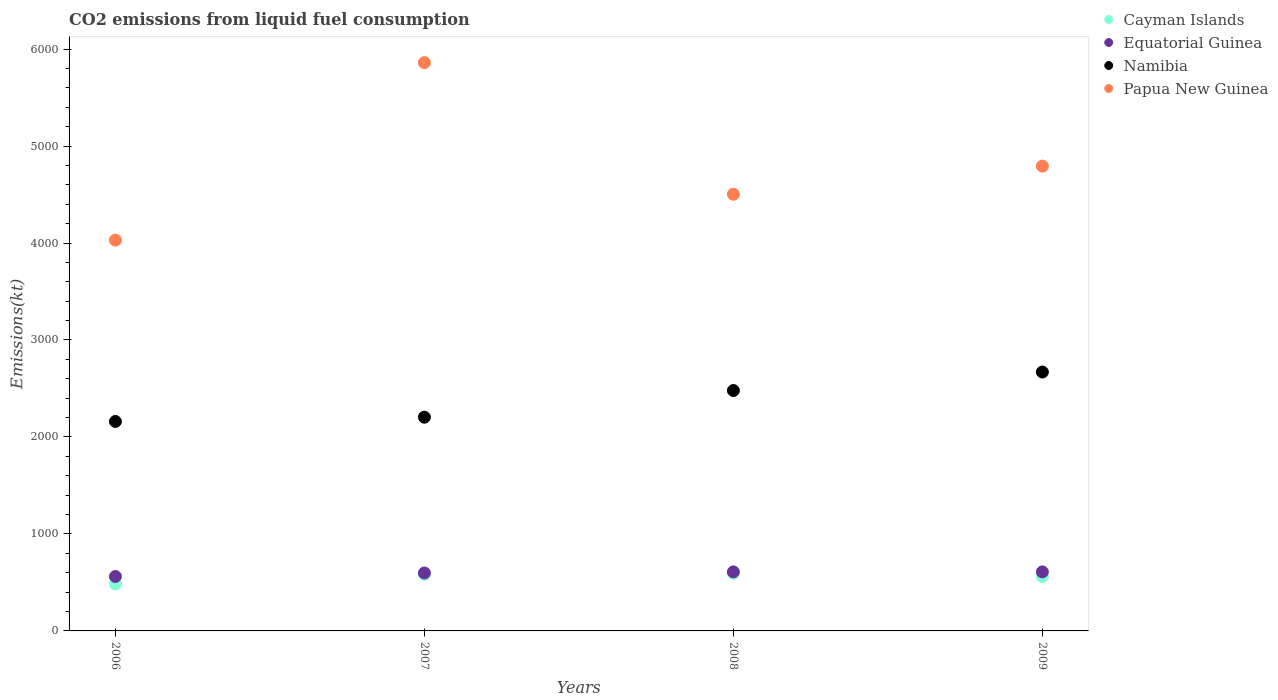What is the amount of CO2 emitted in Namibia in 2009?
Provide a short and direct response. 2669.58. Across all years, what is the maximum amount of CO2 emitted in Namibia?
Offer a very short reply. 2669.58. Across all years, what is the minimum amount of CO2 emitted in Papua New Guinea?
Provide a short and direct response. 4030.03. What is the total amount of CO2 emitted in Papua New Guinea in the graph?
Ensure brevity in your answer.  1.92e+04. What is the difference between the amount of CO2 emitted in Cayman Islands in 2006 and that in 2008?
Give a very brief answer. -110.01. What is the difference between the amount of CO2 emitted in Equatorial Guinea in 2006 and the amount of CO2 emitted in Cayman Islands in 2008?
Offer a very short reply. -33. What is the average amount of CO2 emitted in Cayman Islands per year?
Keep it short and to the point. 555.55. In the year 2007, what is the difference between the amount of CO2 emitted in Cayman Islands and amount of CO2 emitted in Papua New Guinea?
Offer a terse response. -5276.81. What is the ratio of the amount of CO2 emitted in Namibia in 2006 to that in 2008?
Make the answer very short. 0.87. What is the difference between the highest and the second highest amount of CO2 emitted in Cayman Islands?
Your answer should be very brief. 11. What is the difference between the highest and the lowest amount of CO2 emitted in Papua New Guinea?
Offer a very short reply. 1829.83. Is the sum of the amount of CO2 emitted in Namibia in 2008 and 2009 greater than the maximum amount of CO2 emitted in Equatorial Guinea across all years?
Keep it short and to the point. Yes. Does the amount of CO2 emitted in Cayman Islands monotonically increase over the years?
Your answer should be compact. No. Is the amount of CO2 emitted in Papua New Guinea strictly greater than the amount of CO2 emitted in Cayman Islands over the years?
Your answer should be very brief. Yes. How many dotlines are there?
Offer a terse response. 4. What is the difference between two consecutive major ticks on the Y-axis?
Your answer should be compact. 1000. Are the values on the major ticks of Y-axis written in scientific E-notation?
Offer a very short reply. No. Where does the legend appear in the graph?
Provide a short and direct response. Top right. How many legend labels are there?
Your answer should be compact. 4. How are the legend labels stacked?
Offer a terse response. Vertical. What is the title of the graph?
Make the answer very short. CO2 emissions from liquid fuel consumption. What is the label or title of the Y-axis?
Give a very brief answer. Emissions(kt). What is the Emissions(kt) in Cayman Islands in 2006?
Your answer should be very brief. 484.04. What is the Emissions(kt) of Equatorial Guinea in 2006?
Offer a terse response. 561.05. What is the Emissions(kt) of Namibia in 2006?
Make the answer very short. 2159.86. What is the Emissions(kt) in Papua New Guinea in 2006?
Offer a very short reply. 4030.03. What is the Emissions(kt) of Cayman Islands in 2007?
Your answer should be compact. 583.05. What is the Emissions(kt) in Equatorial Guinea in 2007?
Ensure brevity in your answer.  597.72. What is the Emissions(kt) in Namibia in 2007?
Provide a short and direct response. 2203.87. What is the Emissions(kt) in Papua New Guinea in 2007?
Your answer should be compact. 5859.87. What is the Emissions(kt) in Cayman Islands in 2008?
Keep it short and to the point. 594.05. What is the Emissions(kt) of Equatorial Guinea in 2008?
Offer a very short reply. 608.72. What is the Emissions(kt) of Namibia in 2008?
Offer a terse response. 2478.89. What is the Emissions(kt) in Papua New Guinea in 2008?
Ensure brevity in your answer.  4503.08. What is the Emissions(kt) of Cayman Islands in 2009?
Your answer should be very brief. 561.05. What is the Emissions(kt) in Equatorial Guinea in 2009?
Provide a succinct answer. 608.72. What is the Emissions(kt) in Namibia in 2009?
Provide a succinct answer. 2669.58. What is the Emissions(kt) of Papua New Guinea in 2009?
Make the answer very short. 4792.77. Across all years, what is the maximum Emissions(kt) in Cayman Islands?
Give a very brief answer. 594.05. Across all years, what is the maximum Emissions(kt) of Equatorial Guinea?
Your answer should be compact. 608.72. Across all years, what is the maximum Emissions(kt) of Namibia?
Ensure brevity in your answer.  2669.58. Across all years, what is the maximum Emissions(kt) of Papua New Guinea?
Ensure brevity in your answer.  5859.87. Across all years, what is the minimum Emissions(kt) of Cayman Islands?
Give a very brief answer. 484.04. Across all years, what is the minimum Emissions(kt) in Equatorial Guinea?
Make the answer very short. 561.05. Across all years, what is the minimum Emissions(kt) of Namibia?
Make the answer very short. 2159.86. Across all years, what is the minimum Emissions(kt) in Papua New Guinea?
Give a very brief answer. 4030.03. What is the total Emissions(kt) of Cayman Islands in the graph?
Offer a very short reply. 2222.2. What is the total Emissions(kt) of Equatorial Guinea in the graph?
Offer a very short reply. 2376.22. What is the total Emissions(kt) of Namibia in the graph?
Provide a short and direct response. 9512.2. What is the total Emissions(kt) of Papua New Guinea in the graph?
Give a very brief answer. 1.92e+04. What is the difference between the Emissions(kt) in Cayman Islands in 2006 and that in 2007?
Provide a short and direct response. -99.01. What is the difference between the Emissions(kt) in Equatorial Guinea in 2006 and that in 2007?
Your answer should be very brief. -36.67. What is the difference between the Emissions(kt) of Namibia in 2006 and that in 2007?
Provide a succinct answer. -44. What is the difference between the Emissions(kt) in Papua New Guinea in 2006 and that in 2007?
Provide a short and direct response. -1829.83. What is the difference between the Emissions(kt) in Cayman Islands in 2006 and that in 2008?
Offer a very short reply. -110.01. What is the difference between the Emissions(kt) in Equatorial Guinea in 2006 and that in 2008?
Your response must be concise. -47.67. What is the difference between the Emissions(kt) of Namibia in 2006 and that in 2008?
Your answer should be very brief. -319.03. What is the difference between the Emissions(kt) in Papua New Guinea in 2006 and that in 2008?
Keep it short and to the point. -473.04. What is the difference between the Emissions(kt) of Cayman Islands in 2006 and that in 2009?
Your answer should be very brief. -77.01. What is the difference between the Emissions(kt) of Equatorial Guinea in 2006 and that in 2009?
Keep it short and to the point. -47.67. What is the difference between the Emissions(kt) in Namibia in 2006 and that in 2009?
Keep it short and to the point. -509.71. What is the difference between the Emissions(kt) of Papua New Guinea in 2006 and that in 2009?
Keep it short and to the point. -762.74. What is the difference between the Emissions(kt) of Cayman Islands in 2007 and that in 2008?
Ensure brevity in your answer.  -11. What is the difference between the Emissions(kt) in Equatorial Guinea in 2007 and that in 2008?
Make the answer very short. -11. What is the difference between the Emissions(kt) in Namibia in 2007 and that in 2008?
Provide a short and direct response. -275.02. What is the difference between the Emissions(kt) of Papua New Guinea in 2007 and that in 2008?
Provide a succinct answer. 1356.79. What is the difference between the Emissions(kt) of Cayman Islands in 2007 and that in 2009?
Your answer should be very brief. 22. What is the difference between the Emissions(kt) of Equatorial Guinea in 2007 and that in 2009?
Your answer should be compact. -11. What is the difference between the Emissions(kt) in Namibia in 2007 and that in 2009?
Your response must be concise. -465.71. What is the difference between the Emissions(kt) in Papua New Guinea in 2007 and that in 2009?
Offer a very short reply. 1067.1. What is the difference between the Emissions(kt) in Cayman Islands in 2008 and that in 2009?
Keep it short and to the point. 33. What is the difference between the Emissions(kt) of Namibia in 2008 and that in 2009?
Your answer should be very brief. -190.68. What is the difference between the Emissions(kt) in Papua New Guinea in 2008 and that in 2009?
Your response must be concise. -289.69. What is the difference between the Emissions(kt) of Cayman Islands in 2006 and the Emissions(kt) of Equatorial Guinea in 2007?
Offer a terse response. -113.68. What is the difference between the Emissions(kt) in Cayman Islands in 2006 and the Emissions(kt) in Namibia in 2007?
Keep it short and to the point. -1719.82. What is the difference between the Emissions(kt) in Cayman Islands in 2006 and the Emissions(kt) in Papua New Guinea in 2007?
Make the answer very short. -5375.82. What is the difference between the Emissions(kt) of Equatorial Guinea in 2006 and the Emissions(kt) of Namibia in 2007?
Your answer should be very brief. -1642.82. What is the difference between the Emissions(kt) in Equatorial Guinea in 2006 and the Emissions(kt) in Papua New Guinea in 2007?
Your response must be concise. -5298.81. What is the difference between the Emissions(kt) of Namibia in 2006 and the Emissions(kt) of Papua New Guinea in 2007?
Keep it short and to the point. -3700. What is the difference between the Emissions(kt) in Cayman Islands in 2006 and the Emissions(kt) in Equatorial Guinea in 2008?
Provide a succinct answer. -124.68. What is the difference between the Emissions(kt) in Cayman Islands in 2006 and the Emissions(kt) in Namibia in 2008?
Give a very brief answer. -1994.85. What is the difference between the Emissions(kt) of Cayman Islands in 2006 and the Emissions(kt) of Papua New Guinea in 2008?
Provide a succinct answer. -4019.03. What is the difference between the Emissions(kt) in Equatorial Guinea in 2006 and the Emissions(kt) in Namibia in 2008?
Your response must be concise. -1917.84. What is the difference between the Emissions(kt) in Equatorial Guinea in 2006 and the Emissions(kt) in Papua New Guinea in 2008?
Your answer should be very brief. -3942.03. What is the difference between the Emissions(kt) of Namibia in 2006 and the Emissions(kt) of Papua New Guinea in 2008?
Your answer should be very brief. -2343.21. What is the difference between the Emissions(kt) in Cayman Islands in 2006 and the Emissions(kt) in Equatorial Guinea in 2009?
Provide a short and direct response. -124.68. What is the difference between the Emissions(kt) of Cayman Islands in 2006 and the Emissions(kt) of Namibia in 2009?
Offer a very short reply. -2185.53. What is the difference between the Emissions(kt) of Cayman Islands in 2006 and the Emissions(kt) of Papua New Guinea in 2009?
Offer a terse response. -4308.73. What is the difference between the Emissions(kt) in Equatorial Guinea in 2006 and the Emissions(kt) in Namibia in 2009?
Give a very brief answer. -2108.53. What is the difference between the Emissions(kt) in Equatorial Guinea in 2006 and the Emissions(kt) in Papua New Guinea in 2009?
Provide a succinct answer. -4231.72. What is the difference between the Emissions(kt) of Namibia in 2006 and the Emissions(kt) of Papua New Guinea in 2009?
Ensure brevity in your answer.  -2632.91. What is the difference between the Emissions(kt) in Cayman Islands in 2007 and the Emissions(kt) in Equatorial Guinea in 2008?
Ensure brevity in your answer.  -25.67. What is the difference between the Emissions(kt) in Cayman Islands in 2007 and the Emissions(kt) in Namibia in 2008?
Your answer should be very brief. -1895.84. What is the difference between the Emissions(kt) of Cayman Islands in 2007 and the Emissions(kt) of Papua New Guinea in 2008?
Your answer should be very brief. -3920.02. What is the difference between the Emissions(kt) in Equatorial Guinea in 2007 and the Emissions(kt) in Namibia in 2008?
Your response must be concise. -1881.17. What is the difference between the Emissions(kt) in Equatorial Guinea in 2007 and the Emissions(kt) in Papua New Guinea in 2008?
Your response must be concise. -3905.36. What is the difference between the Emissions(kt) of Namibia in 2007 and the Emissions(kt) of Papua New Guinea in 2008?
Provide a succinct answer. -2299.21. What is the difference between the Emissions(kt) of Cayman Islands in 2007 and the Emissions(kt) of Equatorial Guinea in 2009?
Make the answer very short. -25.67. What is the difference between the Emissions(kt) in Cayman Islands in 2007 and the Emissions(kt) in Namibia in 2009?
Keep it short and to the point. -2086.52. What is the difference between the Emissions(kt) in Cayman Islands in 2007 and the Emissions(kt) in Papua New Guinea in 2009?
Give a very brief answer. -4209.72. What is the difference between the Emissions(kt) of Equatorial Guinea in 2007 and the Emissions(kt) of Namibia in 2009?
Your answer should be very brief. -2071.86. What is the difference between the Emissions(kt) of Equatorial Guinea in 2007 and the Emissions(kt) of Papua New Guinea in 2009?
Provide a succinct answer. -4195.05. What is the difference between the Emissions(kt) in Namibia in 2007 and the Emissions(kt) in Papua New Guinea in 2009?
Ensure brevity in your answer.  -2588.9. What is the difference between the Emissions(kt) in Cayman Islands in 2008 and the Emissions(kt) in Equatorial Guinea in 2009?
Ensure brevity in your answer.  -14.67. What is the difference between the Emissions(kt) of Cayman Islands in 2008 and the Emissions(kt) of Namibia in 2009?
Your answer should be compact. -2075.52. What is the difference between the Emissions(kt) of Cayman Islands in 2008 and the Emissions(kt) of Papua New Guinea in 2009?
Offer a terse response. -4198.72. What is the difference between the Emissions(kt) of Equatorial Guinea in 2008 and the Emissions(kt) of Namibia in 2009?
Your answer should be compact. -2060.85. What is the difference between the Emissions(kt) of Equatorial Guinea in 2008 and the Emissions(kt) of Papua New Guinea in 2009?
Provide a short and direct response. -4184.05. What is the difference between the Emissions(kt) of Namibia in 2008 and the Emissions(kt) of Papua New Guinea in 2009?
Provide a short and direct response. -2313.88. What is the average Emissions(kt) of Cayman Islands per year?
Provide a short and direct response. 555.55. What is the average Emissions(kt) of Equatorial Guinea per year?
Your answer should be compact. 594.05. What is the average Emissions(kt) in Namibia per year?
Provide a short and direct response. 2378.05. What is the average Emissions(kt) in Papua New Guinea per year?
Ensure brevity in your answer.  4796.44. In the year 2006, what is the difference between the Emissions(kt) in Cayman Islands and Emissions(kt) in Equatorial Guinea?
Ensure brevity in your answer.  -77.01. In the year 2006, what is the difference between the Emissions(kt) of Cayman Islands and Emissions(kt) of Namibia?
Offer a very short reply. -1675.82. In the year 2006, what is the difference between the Emissions(kt) of Cayman Islands and Emissions(kt) of Papua New Guinea?
Provide a short and direct response. -3545.99. In the year 2006, what is the difference between the Emissions(kt) in Equatorial Guinea and Emissions(kt) in Namibia?
Give a very brief answer. -1598.81. In the year 2006, what is the difference between the Emissions(kt) of Equatorial Guinea and Emissions(kt) of Papua New Guinea?
Offer a terse response. -3468.98. In the year 2006, what is the difference between the Emissions(kt) in Namibia and Emissions(kt) in Papua New Guinea?
Make the answer very short. -1870.17. In the year 2007, what is the difference between the Emissions(kt) in Cayman Islands and Emissions(kt) in Equatorial Guinea?
Ensure brevity in your answer.  -14.67. In the year 2007, what is the difference between the Emissions(kt) in Cayman Islands and Emissions(kt) in Namibia?
Offer a very short reply. -1620.81. In the year 2007, what is the difference between the Emissions(kt) of Cayman Islands and Emissions(kt) of Papua New Guinea?
Provide a short and direct response. -5276.81. In the year 2007, what is the difference between the Emissions(kt) in Equatorial Guinea and Emissions(kt) in Namibia?
Ensure brevity in your answer.  -1606.15. In the year 2007, what is the difference between the Emissions(kt) of Equatorial Guinea and Emissions(kt) of Papua New Guinea?
Your response must be concise. -5262.15. In the year 2007, what is the difference between the Emissions(kt) of Namibia and Emissions(kt) of Papua New Guinea?
Give a very brief answer. -3656. In the year 2008, what is the difference between the Emissions(kt) of Cayman Islands and Emissions(kt) of Equatorial Guinea?
Offer a terse response. -14.67. In the year 2008, what is the difference between the Emissions(kt) of Cayman Islands and Emissions(kt) of Namibia?
Your answer should be compact. -1884.84. In the year 2008, what is the difference between the Emissions(kt) of Cayman Islands and Emissions(kt) of Papua New Guinea?
Provide a succinct answer. -3909.02. In the year 2008, what is the difference between the Emissions(kt) in Equatorial Guinea and Emissions(kt) in Namibia?
Offer a terse response. -1870.17. In the year 2008, what is the difference between the Emissions(kt) of Equatorial Guinea and Emissions(kt) of Papua New Guinea?
Offer a terse response. -3894.35. In the year 2008, what is the difference between the Emissions(kt) in Namibia and Emissions(kt) in Papua New Guinea?
Provide a short and direct response. -2024.18. In the year 2009, what is the difference between the Emissions(kt) of Cayman Islands and Emissions(kt) of Equatorial Guinea?
Make the answer very short. -47.67. In the year 2009, what is the difference between the Emissions(kt) in Cayman Islands and Emissions(kt) in Namibia?
Provide a short and direct response. -2108.53. In the year 2009, what is the difference between the Emissions(kt) of Cayman Islands and Emissions(kt) of Papua New Guinea?
Offer a very short reply. -4231.72. In the year 2009, what is the difference between the Emissions(kt) of Equatorial Guinea and Emissions(kt) of Namibia?
Your response must be concise. -2060.85. In the year 2009, what is the difference between the Emissions(kt) of Equatorial Guinea and Emissions(kt) of Papua New Guinea?
Offer a very short reply. -4184.05. In the year 2009, what is the difference between the Emissions(kt) in Namibia and Emissions(kt) in Papua New Guinea?
Your answer should be compact. -2123.19. What is the ratio of the Emissions(kt) of Cayman Islands in 2006 to that in 2007?
Your answer should be compact. 0.83. What is the ratio of the Emissions(kt) of Equatorial Guinea in 2006 to that in 2007?
Give a very brief answer. 0.94. What is the ratio of the Emissions(kt) in Papua New Guinea in 2006 to that in 2007?
Your answer should be very brief. 0.69. What is the ratio of the Emissions(kt) of Cayman Islands in 2006 to that in 2008?
Keep it short and to the point. 0.81. What is the ratio of the Emissions(kt) in Equatorial Guinea in 2006 to that in 2008?
Ensure brevity in your answer.  0.92. What is the ratio of the Emissions(kt) in Namibia in 2006 to that in 2008?
Your response must be concise. 0.87. What is the ratio of the Emissions(kt) in Papua New Guinea in 2006 to that in 2008?
Provide a succinct answer. 0.9. What is the ratio of the Emissions(kt) in Cayman Islands in 2006 to that in 2009?
Offer a very short reply. 0.86. What is the ratio of the Emissions(kt) of Equatorial Guinea in 2006 to that in 2009?
Ensure brevity in your answer.  0.92. What is the ratio of the Emissions(kt) in Namibia in 2006 to that in 2009?
Offer a very short reply. 0.81. What is the ratio of the Emissions(kt) of Papua New Guinea in 2006 to that in 2009?
Your answer should be compact. 0.84. What is the ratio of the Emissions(kt) of Cayman Islands in 2007 to that in 2008?
Your response must be concise. 0.98. What is the ratio of the Emissions(kt) in Equatorial Guinea in 2007 to that in 2008?
Your answer should be very brief. 0.98. What is the ratio of the Emissions(kt) in Namibia in 2007 to that in 2008?
Your response must be concise. 0.89. What is the ratio of the Emissions(kt) of Papua New Guinea in 2007 to that in 2008?
Your answer should be very brief. 1.3. What is the ratio of the Emissions(kt) in Cayman Islands in 2007 to that in 2009?
Offer a very short reply. 1.04. What is the ratio of the Emissions(kt) of Equatorial Guinea in 2007 to that in 2009?
Offer a terse response. 0.98. What is the ratio of the Emissions(kt) of Namibia in 2007 to that in 2009?
Your answer should be very brief. 0.83. What is the ratio of the Emissions(kt) in Papua New Guinea in 2007 to that in 2009?
Give a very brief answer. 1.22. What is the ratio of the Emissions(kt) in Cayman Islands in 2008 to that in 2009?
Your answer should be compact. 1.06. What is the ratio of the Emissions(kt) of Equatorial Guinea in 2008 to that in 2009?
Offer a very short reply. 1. What is the ratio of the Emissions(kt) of Papua New Guinea in 2008 to that in 2009?
Offer a very short reply. 0.94. What is the difference between the highest and the second highest Emissions(kt) of Cayman Islands?
Offer a terse response. 11. What is the difference between the highest and the second highest Emissions(kt) in Namibia?
Offer a very short reply. 190.68. What is the difference between the highest and the second highest Emissions(kt) of Papua New Guinea?
Provide a succinct answer. 1067.1. What is the difference between the highest and the lowest Emissions(kt) in Cayman Islands?
Your response must be concise. 110.01. What is the difference between the highest and the lowest Emissions(kt) of Equatorial Guinea?
Your answer should be compact. 47.67. What is the difference between the highest and the lowest Emissions(kt) of Namibia?
Provide a succinct answer. 509.71. What is the difference between the highest and the lowest Emissions(kt) of Papua New Guinea?
Offer a very short reply. 1829.83. 